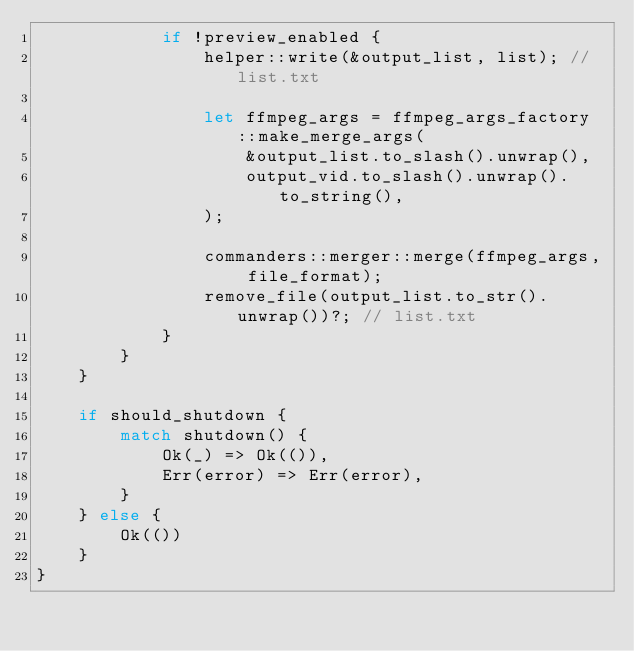<code> <loc_0><loc_0><loc_500><loc_500><_Rust_>            if !preview_enabled {
                helper::write(&output_list, list); // list.txt

                let ffmpeg_args = ffmpeg_args_factory::make_merge_args(
                    &output_list.to_slash().unwrap(),
                    output_vid.to_slash().unwrap().to_string(),
                );

                commanders::merger::merge(ffmpeg_args, file_format);
                remove_file(output_list.to_str().unwrap())?; // list.txt
            }
        }
    }

    if should_shutdown {
        match shutdown() {
            Ok(_) => Ok(()),
            Err(error) => Err(error),
        }
    } else {
        Ok(())
    }
}
</code> 